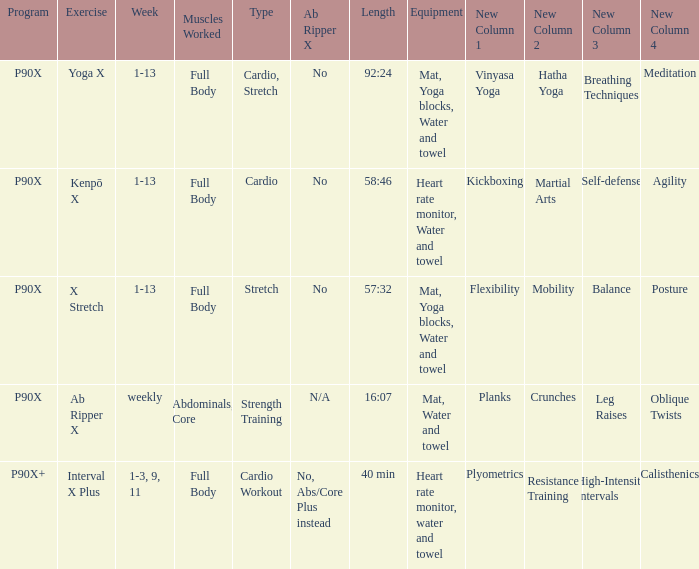What is the exercise when the equipment is heart rate monitor, water and towel? Kenpō X, Interval X Plus. 